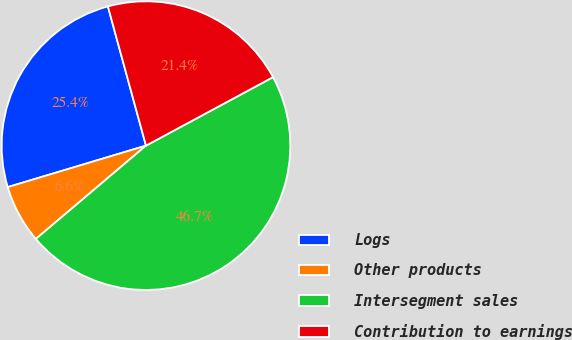Convert chart to OTSL. <chart><loc_0><loc_0><loc_500><loc_500><pie_chart><fcel>Logs<fcel>Other products<fcel>Intersegment sales<fcel>Contribution to earnings<nl><fcel>25.39%<fcel>6.55%<fcel>46.68%<fcel>21.38%<nl></chart> 